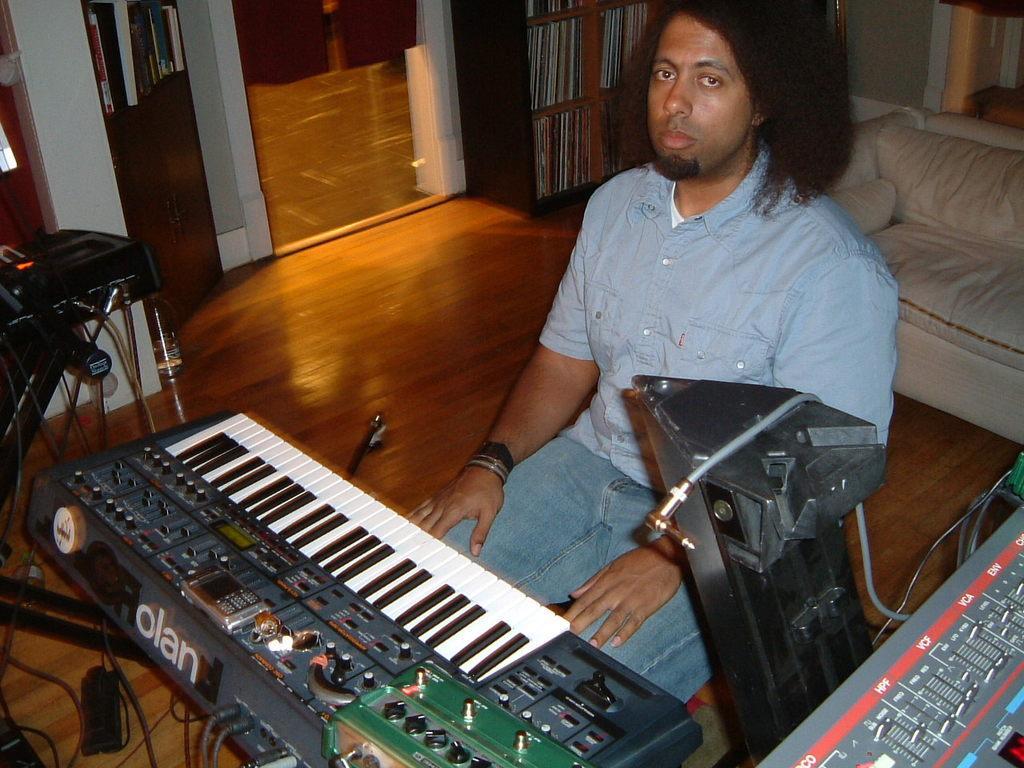How would you summarize this image in a sentence or two? In this picture I can see a person sitting on the chair, there is a piano, there are books in the racks, there is a couch and there are some other objects. 